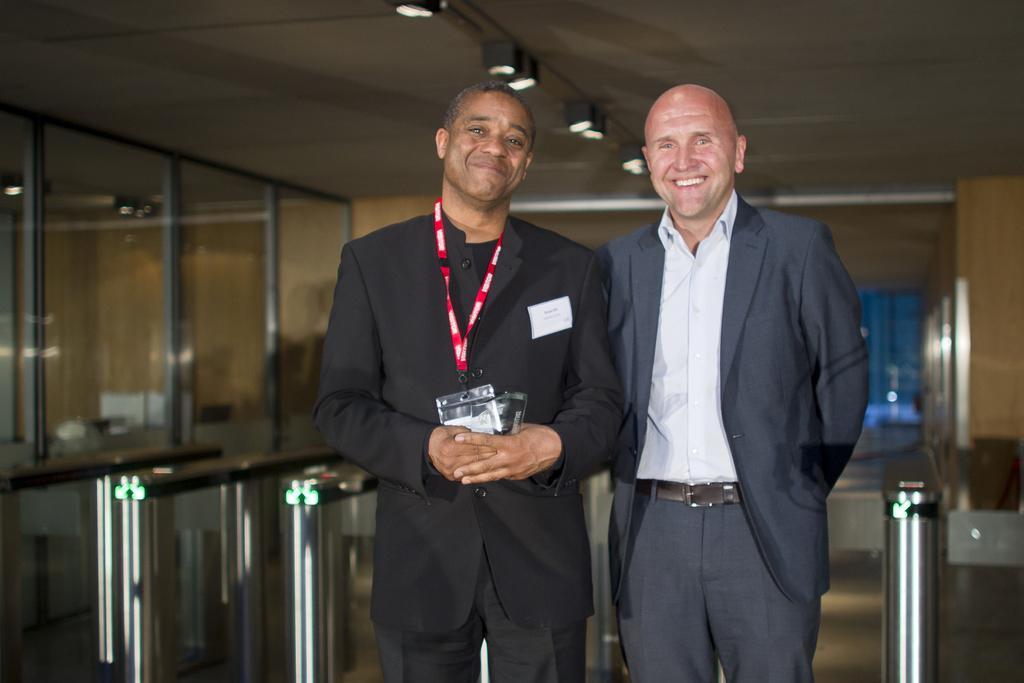In one or two sentences, can you explain what this image depicts? In this picture I can see 2 men who are standing in front and I see that they are wearing formal dress and smiling. In the background I can see the glasses, holes and the rods. On the top of this picture I can see the lights on the ceiling. 